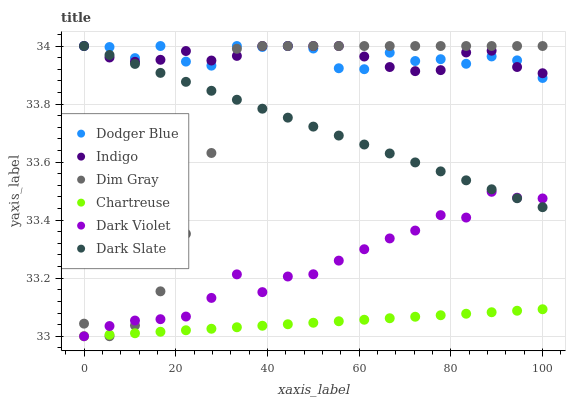Does Chartreuse have the minimum area under the curve?
Answer yes or no. Yes. Does Dodger Blue have the maximum area under the curve?
Answer yes or no. Yes. Does Indigo have the minimum area under the curve?
Answer yes or no. No. Does Indigo have the maximum area under the curve?
Answer yes or no. No. Is Chartreuse the smoothest?
Answer yes or no. Yes. Is Dodger Blue the roughest?
Answer yes or no. Yes. Is Indigo the smoothest?
Answer yes or no. No. Is Indigo the roughest?
Answer yes or no. No. Does Dark Violet have the lowest value?
Answer yes or no. Yes. Does Indigo have the lowest value?
Answer yes or no. No. Does Dodger Blue have the highest value?
Answer yes or no. Yes. Does Dark Violet have the highest value?
Answer yes or no. No. Is Chartreuse less than Dodger Blue?
Answer yes or no. Yes. Is Indigo greater than Chartreuse?
Answer yes or no. Yes. Does Dark Violet intersect Dim Gray?
Answer yes or no. Yes. Is Dark Violet less than Dim Gray?
Answer yes or no. No. Is Dark Violet greater than Dim Gray?
Answer yes or no. No. Does Chartreuse intersect Dodger Blue?
Answer yes or no. No. 